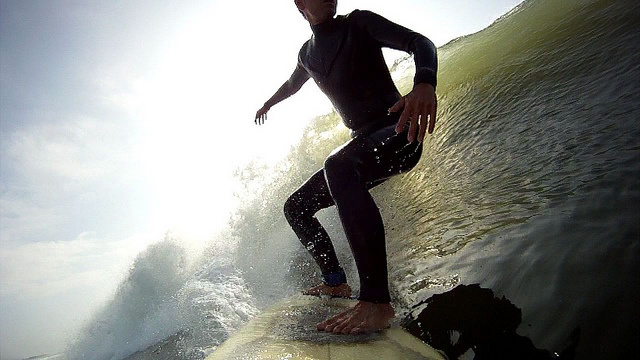Describe the objects in this image and their specific colors. I can see people in gray, black, and ivory tones and surfboard in gray, darkgray, black, and darkgreen tones in this image. 